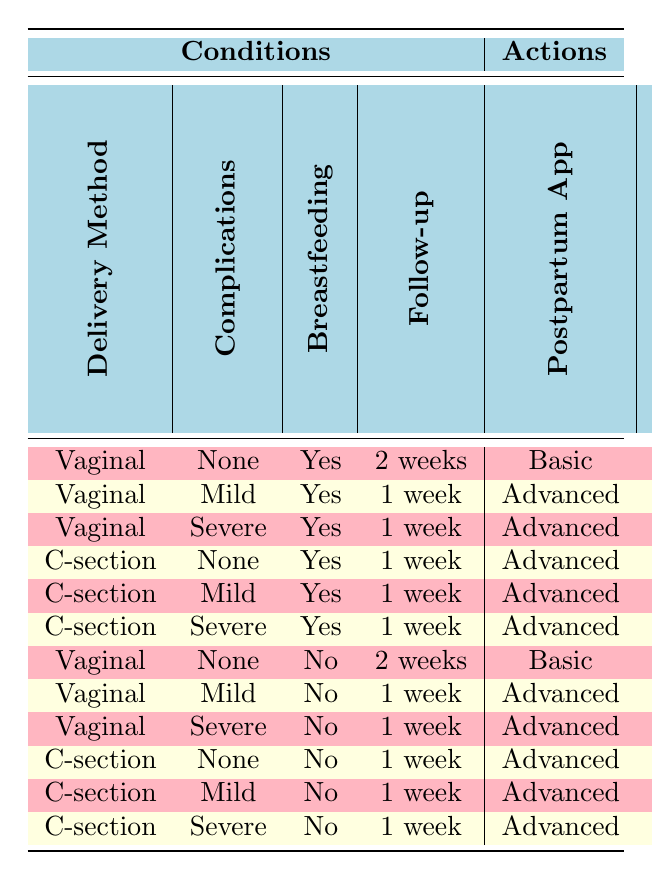What follow-up appointment is recommended for a vaginal delivery with severe complications while breastfeeding? The row corresponding to "Vaginal" delivery, "Severe" complications, and "Yes" for breastfeeding indicates "1 week" for follow-up appointments.
Answer: 1 week What is the recommended postpartum app for a C-section with mild complications and no breastfeeding? The row for "C-section," "Mild" complications, and "No" breastfeeding shows "Advanced" for the postpartum app.
Answer: Advanced Is lactation consultant support required after a vaginal delivery with no complications if the mother is not breastfeeding? The row for "Vaginal," "None" complications, and "No" breastfeeding states "Not Required" for the lactation consultant.
Answer: Not Required How many actions involve starting pelvic floor exercises after a C-section with severe complications and breastfeeding? The rule for "C-section," "Severe" complications, and "Yes" for breastfeeding specifies "Consult physiotherapist" for pelvic floor exercises, indicating only one action.
Answer: 1 What is the difference between the follow-up appointment for a vaginal delivery with mild complications breastfeeding and a C-section with mild complications breastfeeding? Both conditions lead to a "1 week" follow-up appointment; thus, the difference is zero, meaning they require the same follow-up duration.
Answer: 0 How many follow-up appointments are indicated for both C-section deliveries with any complications if breastfeeding? All rows for "C-section" with "None," "Mild," and "Severe" complications for breastfeeding show "1 week" for follow-up appointments. Therefore, there are three rows indicating this follow-up duration.
Answer: 3 Is mental health screening due in one month after a vaginal delivery with no complications and breastfeeding? The row for "Vaginal," "None" complications, and "Yes" for breastfeeding indicates "1 month" for mental health screening, making this fact true.
Answer: Yes What is the action plan for a vaginal delivery with severe complications and no breastfeeding? The row for "Vaginal," "Severe," and "No" breastfeeding specifies "1 week" for follow-up, "Advanced" for the postpartum app, "Not Required" for lactation consultant, "Consult physiotherapist" for pelvic floor exercises, and "1 week" for mental health screening.
Answer: Follow-up: 1 week, App: Advanced, Consultant: Not Required, Exercises: Consult physiotherapist, Screening: 1 week 